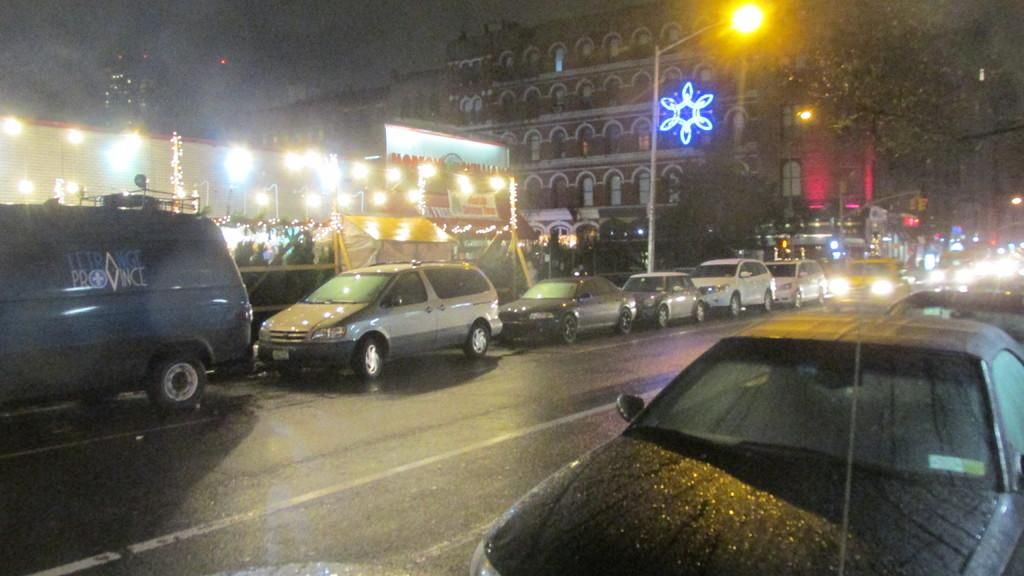What can be seen on the road in the image? There are vehicles on the road in the image. What type of structures can be seen in the image? There are buildings visible in the image. What is the purpose of the tall pole in the image? There is a light pole in the image, which is likely used for illuminating the area. What can be seen in the background of the image? Lights are present in the background of the image. How far is the distance between the two oil rigs in the image? There are no oil rigs present in the image; it features vehicles on a road and buildings in the background. What type of rest can be taken in the image? There is no indication of a place to rest in the image; it primarily shows vehicles on a road and buildings in the background. 